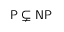<formula> <loc_0><loc_0><loc_500><loc_500>{ P } \subsetneq { N P }</formula> 